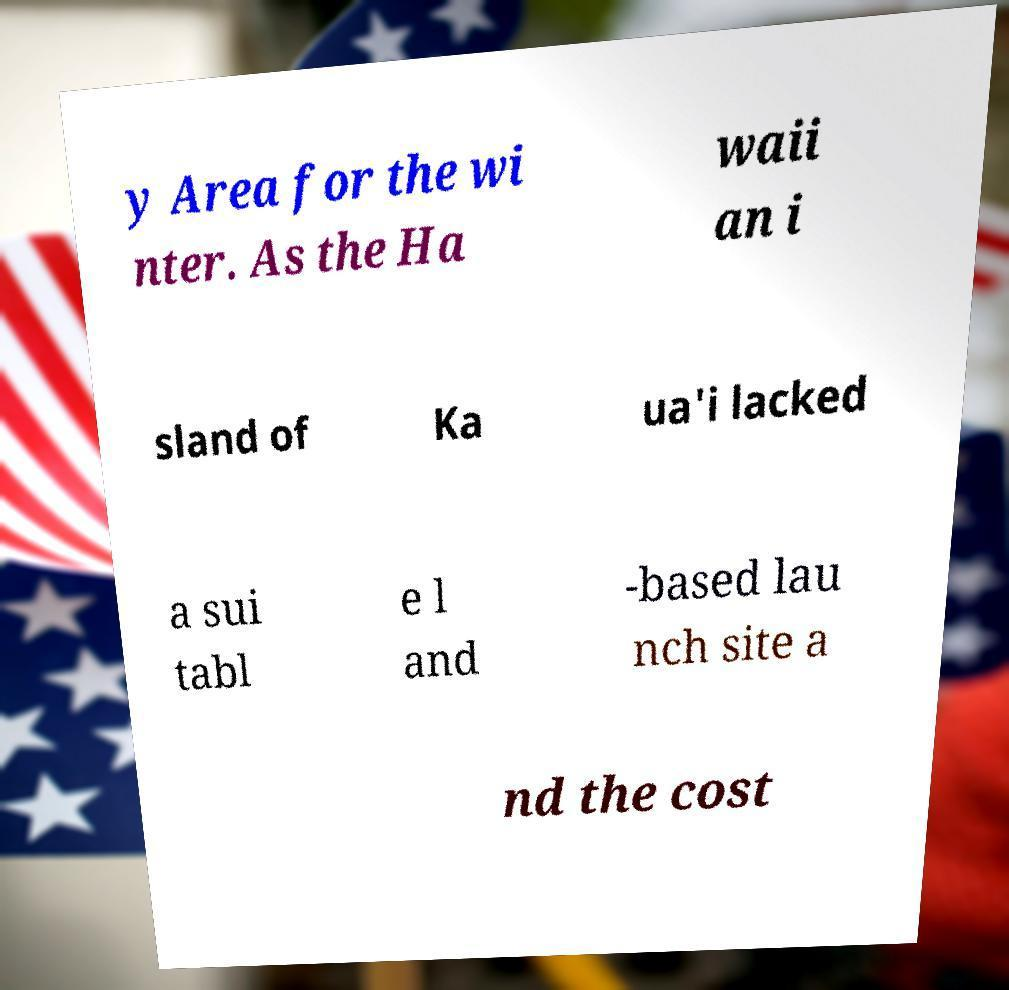Could you extract and type out the text from this image? y Area for the wi nter. As the Ha waii an i sland of Ka ua'i lacked a sui tabl e l and -based lau nch site a nd the cost 